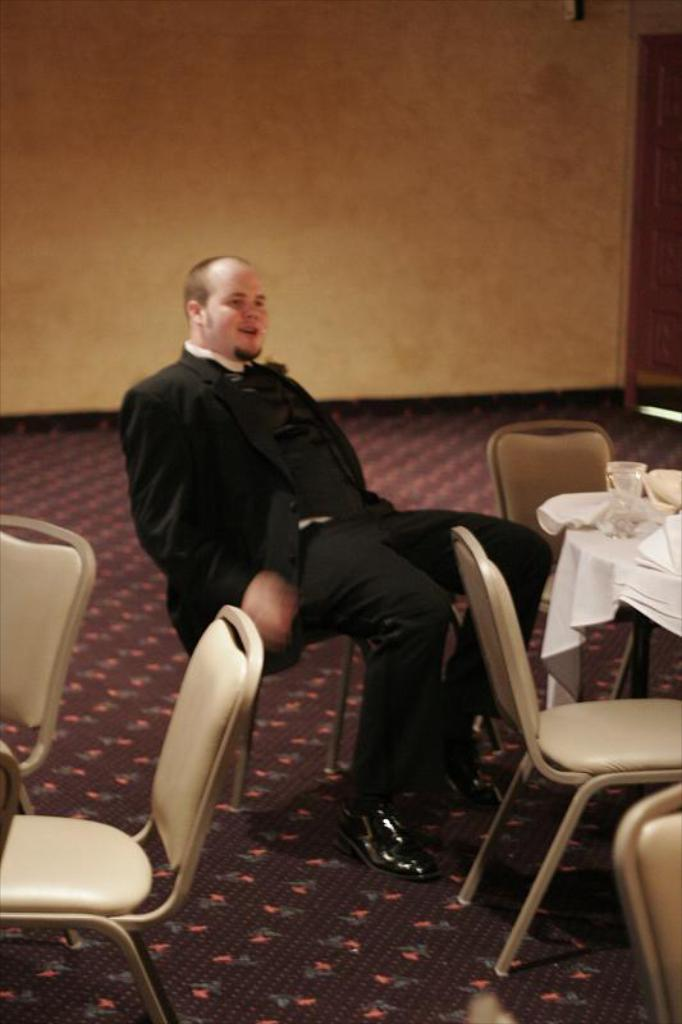What is the man in the image doing? The man is sitting in the image. How many chairs are visible in the image? There are 5 chairs in the image. What is the main piece of furniture in the image? There is a table in the image. What is on top of the table? There are items on the table. What can be seen in the background of the image? There is a wall in the background of the image. What type of wilderness can be seen through the window in the image? There is no window or wilderness present in the image. What color is the coat hanging on the wall in the image? There is no coat present in the image. 